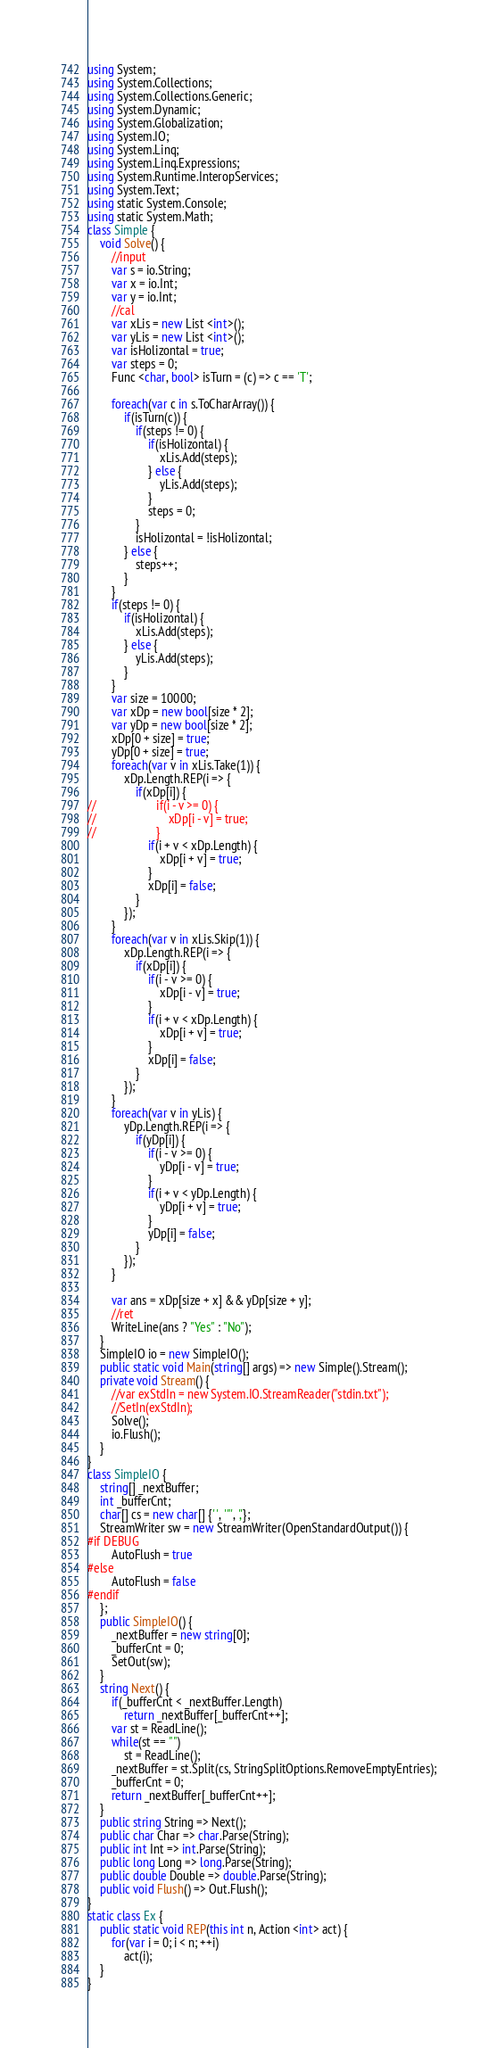<code> <loc_0><loc_0><loc_500><loc_500><_C#_>using System;
using System.Collections;
using System.Collections.Generic;
using System.Dynamic;
using System.Globalization;
using System.IO;
using System.Linq;
using System.Linq.Expressions;
using System.Runtime.InteropServices;
using System.Text;
using static System.Console;
using static System.Math;
class Simple {
    void Solve() {
        //input        
        var s = io.String;
        var x = io.Int;
        var y = io.Int;
        //cal        
        var xLis = new List <int>();
        var yLis = new List <int>();
        var isHolizontal = true;
        var steps = 0;
        Func <char, bool> isTurn = (c) => c == 'T';
        
        foreach(var c in s.ToCharArray()) {
            if(isTurn(c)) {
                if(steps != 0) {
                    if(isHolizontal) {
                        xLis.Add(steps);
                    } else {
                        yLis.Add(steps);
                    }
                    steps = 0;
                }
                isHolizontal = !isHolizontal;
            } else {
                steps++;
            }
        }
        if(steps != 0) {
            if(isHolizontal) {
                xLis.Add(steps);
            } else {
                yLis.Add(steps);
            }
        }
        var size = 10000;
        var xDp = new bool[size * 2];
        var yDp = new bool[size * 2];
        xDp[0 + size] = true;
        yDp[0 + size] = true;
        foreach(var v in xLis.Take(1)) {
            xDp.Length.REP(i => {
                if(xDp[i]) {
//                    if(i - v >= 0) {
//                        xDp[i - v] = true;
//                    }
                    if(i + v < xDp.Length) {
                        xDp[i + v] = true;
                    }
                    xDp[i] = false;
                }
            });
        }
        foreach(var v in xLis.Skip(1)) {
            xDp.Length.REP(i => {
                if(xDp[i]) {
                    if(i - v >= 0) {
                        xDp[i - v] = true;
                    }
                    if(i + v < xDp.Length) {
                        xDp[i + v] = true;
                    }
                    xDp[i] = false;
                }
            });
        }
        foreach(var v in yLis) {
            yDp.Length.REP(i => {
                if(yDp[i]) {
                    if(i - v >= 0) {
                        yDp[i - v] = true;
                    }
                    if(i + v < yDp.Length) {
                        yDp[i + v] = true;
                    }
                    yDp[i] = false;
                }
            });
        }        
        
        var ans = xDp[size + x] && yDp[size + y];
        //ret
        WriteLine(ans ? "Yes" : "No");
    }
    SimpleIO io = new SimpleIO();
    public static void Main(string[] args) => new Simple().Stream();
    private void Stream() {
        //var exStdIn = new System.IO.StreamReader("stdin.txt");
        //SetIn(exStdIn);
        Solve();
        io.Flush();
    }
}
class SimpleIO {
    string[] _nextBuffer;
    int _bufferCnt;
    char[] cs = new char[] {' ', '"', ','};
    StreamWriter sw = new StreamWriter(OpenStandardOutput()) {
#if DEBUG
        AutoFlush = true
#else
        AutoFlush = false
#endif
    };
    public SimpleIO() {
        _nextBuffer = new string[0];
        _bufferCnt = 0;
        SetOut(sw);
    }
    string Next() {
        if(_bufferCnt < _nextBuffer.Length)
            return _nextBuffer[_bufferCnt++];
        var st = ReadLine();
        while(st == "")
            st = ReadLine();
        _nextBuffer = st.Split(cs, StringSplitOptions.RemoveEmptyEntries);
        _bufferCnt = 0;
        return _nextBuffer[_bufferCnt++];
    }
    public string String => Next();
    public char Char => char.Parse(String);
    public int Int => int.Parse(String);
    public long Long => long.Parse(String);
    public double Double => double.Parse(String);
    public void Flush() => Out.Flush();
}
static class Ex {
    public static void REP(this int n, Action <int> act) {
        for(var i = 0; i < n; ++i)
            act(i);
    }
}
</code> 